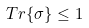<formula> <loc_0><loc_0><loc_500><loc_500>T r \{ \sigma \} \leq 1</formula> 